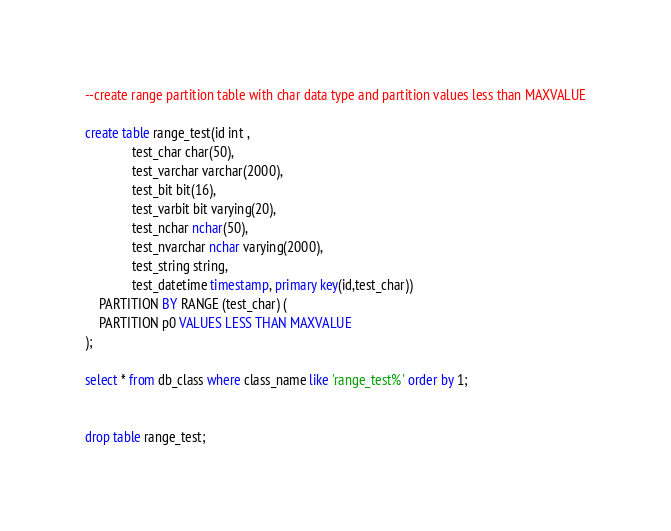Convert code to text. <code><loc_0><loc_0><loc_500><loc_500><_SQL_>--create range partition table with char data type and partition values less than MAXVALUE

create table range_test(id int ,
			  test_char char(50),
			  test_varchar varchar(2000),
			  test_bit bit(16),
			  test_varbit bit varying(20),
			  test_nchar nchar(50),
			  test_nvarchar nchar varying(2000),
			  test_string string,
			  test_datetime timestamp, primary key(id,test_char))
	PARTITION BY RANGE (test_char) (
	PARTITION p0 VALUES LESS THAN MAXVALUE
);

select * from db_class where class_name like 'range_test%' order by 1;


drop table range_test;
</code> 